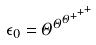Convert formula to latex. <formula><loc_0><loc_0><loc_500><loc_500>\epsilon _ { 0 } = \Theta ^ { \Theta ^ { \Theta ^ { + ^ { + ^ { + } } } } }</formula> 